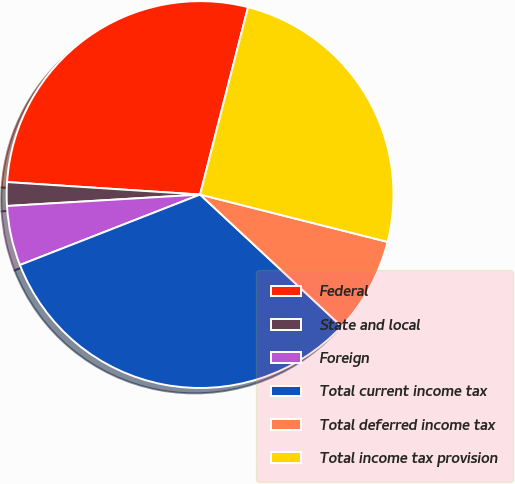<chart> <loc_0><loc_0><loc_500><loc_500><pie_chart><fcel>Federal<fcel>State and local<fcel>Foreign<fcel>Total current income tax<fcel>Total deferred income tax<fcel>Total income tax provision<nl><fcel>27.96%<fcel>1.97%<fcel>4.99%<fcel>32.13%<fcel>8.0%<fcel>24.95%<nl></chart> 